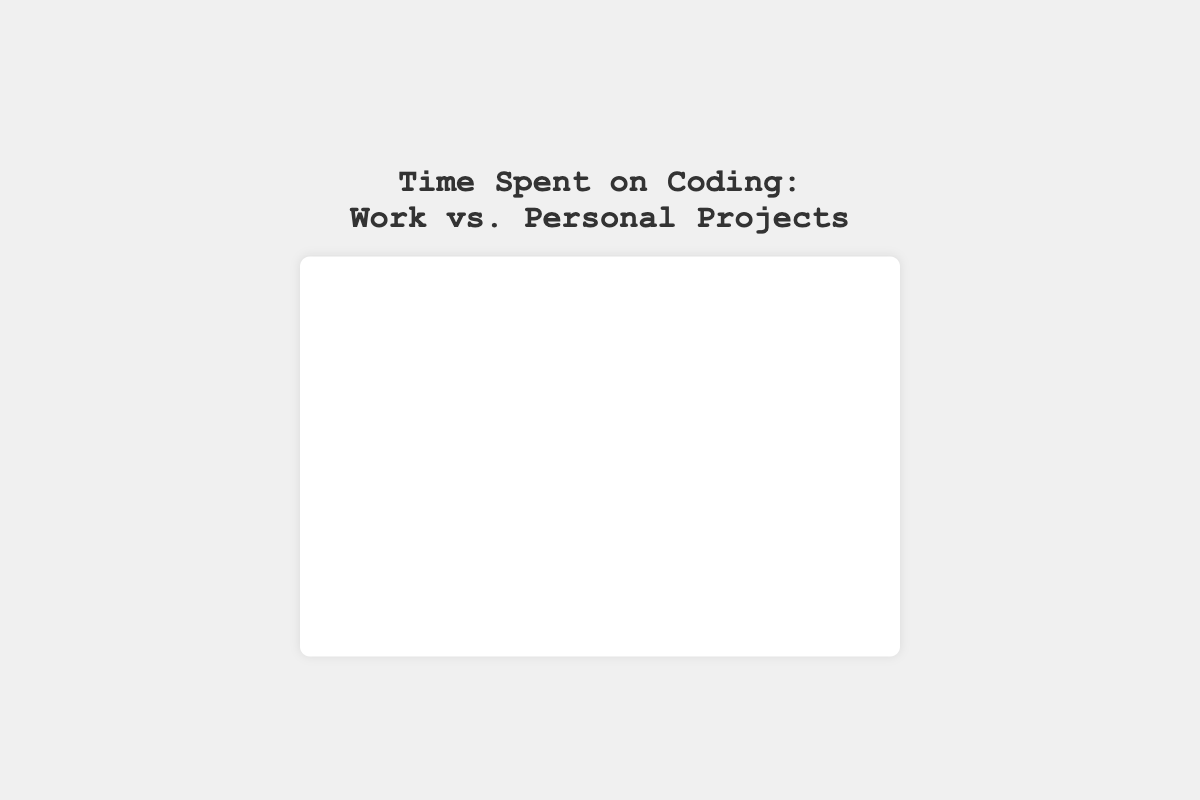What percentage of time is spent on work projects? The pie chart shows the allocation with percentages, and the "Work Projects" segment indicates the percentage value. By looking at the chart, you can see the label that shows the percentage for work projects.
Answer: 77.8% Which type of project has more time spent, work projects or personal projects? The pie chart visually represents the two categories, and you can see that the segment for "Work Projects" is significantly larger than that for "Personal Projects". The percentage labels also show that "Work Projects" has a higher value.
Answer: Work Projects What is the total number of hours spent on coding per week? The total hours can be calculated by summing up the hours spent on "Work Projects" and "Personal Projects". From the data, it’s 35 hours (Work) + 10 hours (Personal) = 45 hours.
Answer: 45 hours How much more time is spent on work projects compared to personal projects? The pie chart shows the individual hours spent. The difference can be calculated as 35 hours (Work) - 10 hours (Personal) = 25 hours.
Answer: 25 hours What proportion of time is spent on personal projects compared to the total time spent on coding? The pie chart indicates that 10 hours are spent on personal projects out of a total of 45 hours. The proportion is 10/45. Simplifying this fraction gives approximately 0.22, or 22.2%.
Answer: 22.2% If the total hours spent on coding increased by 5 hours, and were added to personal projects, what would be the new percentage of time spent on personal projects? Adding 5 hours to the personal projects would make it 15 hours. The new total hours would be 50 hours (45 original + 5 additional). The new percentage for personal projects would be (15/50) * 100% = 30%.
Answer: 30% Which visual segment in the pie chart is larger in size? By observing the pie chart, it’s visually evident which segment covers more area. "Work Projects" covers a larger segment than "Personal Projects".
Answer: Work Projects How does the size of "Personal Projects" section compare visually to "Work Projects"? Visually, the "Personal Projects" segment is smaller than the "Work Projects" segment in the pie chart. This difference also reflects the different number of hours allocated to each.
Answer: Smaller What is the ratio of time spent on work projects to personal projects? The ratio can be calculated directly from the data provided, with 35 hours on "Work Projects" and 10 hours on "Personal Projects". Therefore, the ratio is 35:10, which simplifies to 3.5:1.
Answer: 3.5:1 